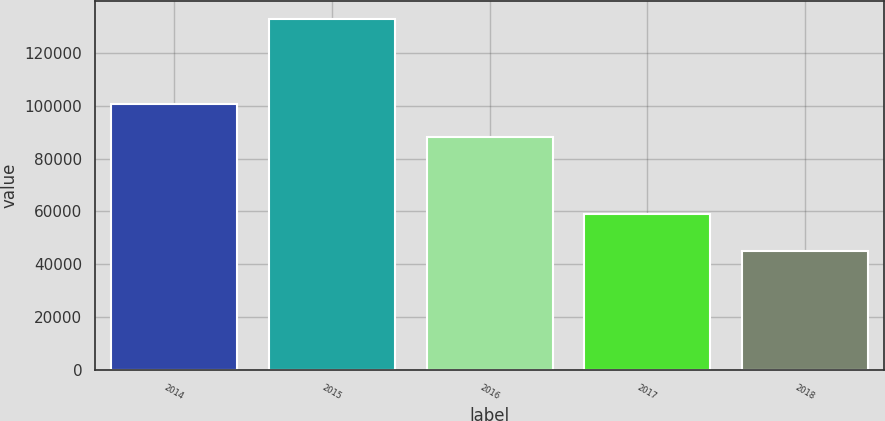Convert chart to OTSL. <chart><loc_0><loc_0><loc_500><loc_500><bar_chart><fcel>2014<fcel>2015<fcel>2016<fcel>2017<fcel>2018<nl><fcel>100673<fcel>133005<fcel>88223<fcel>59183<fcel>44902<nl></chart> 